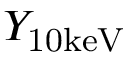<formula> <loc_0><loc_0><loc_500><loc_500>Y _ { 1 0 k e V }</formula> 